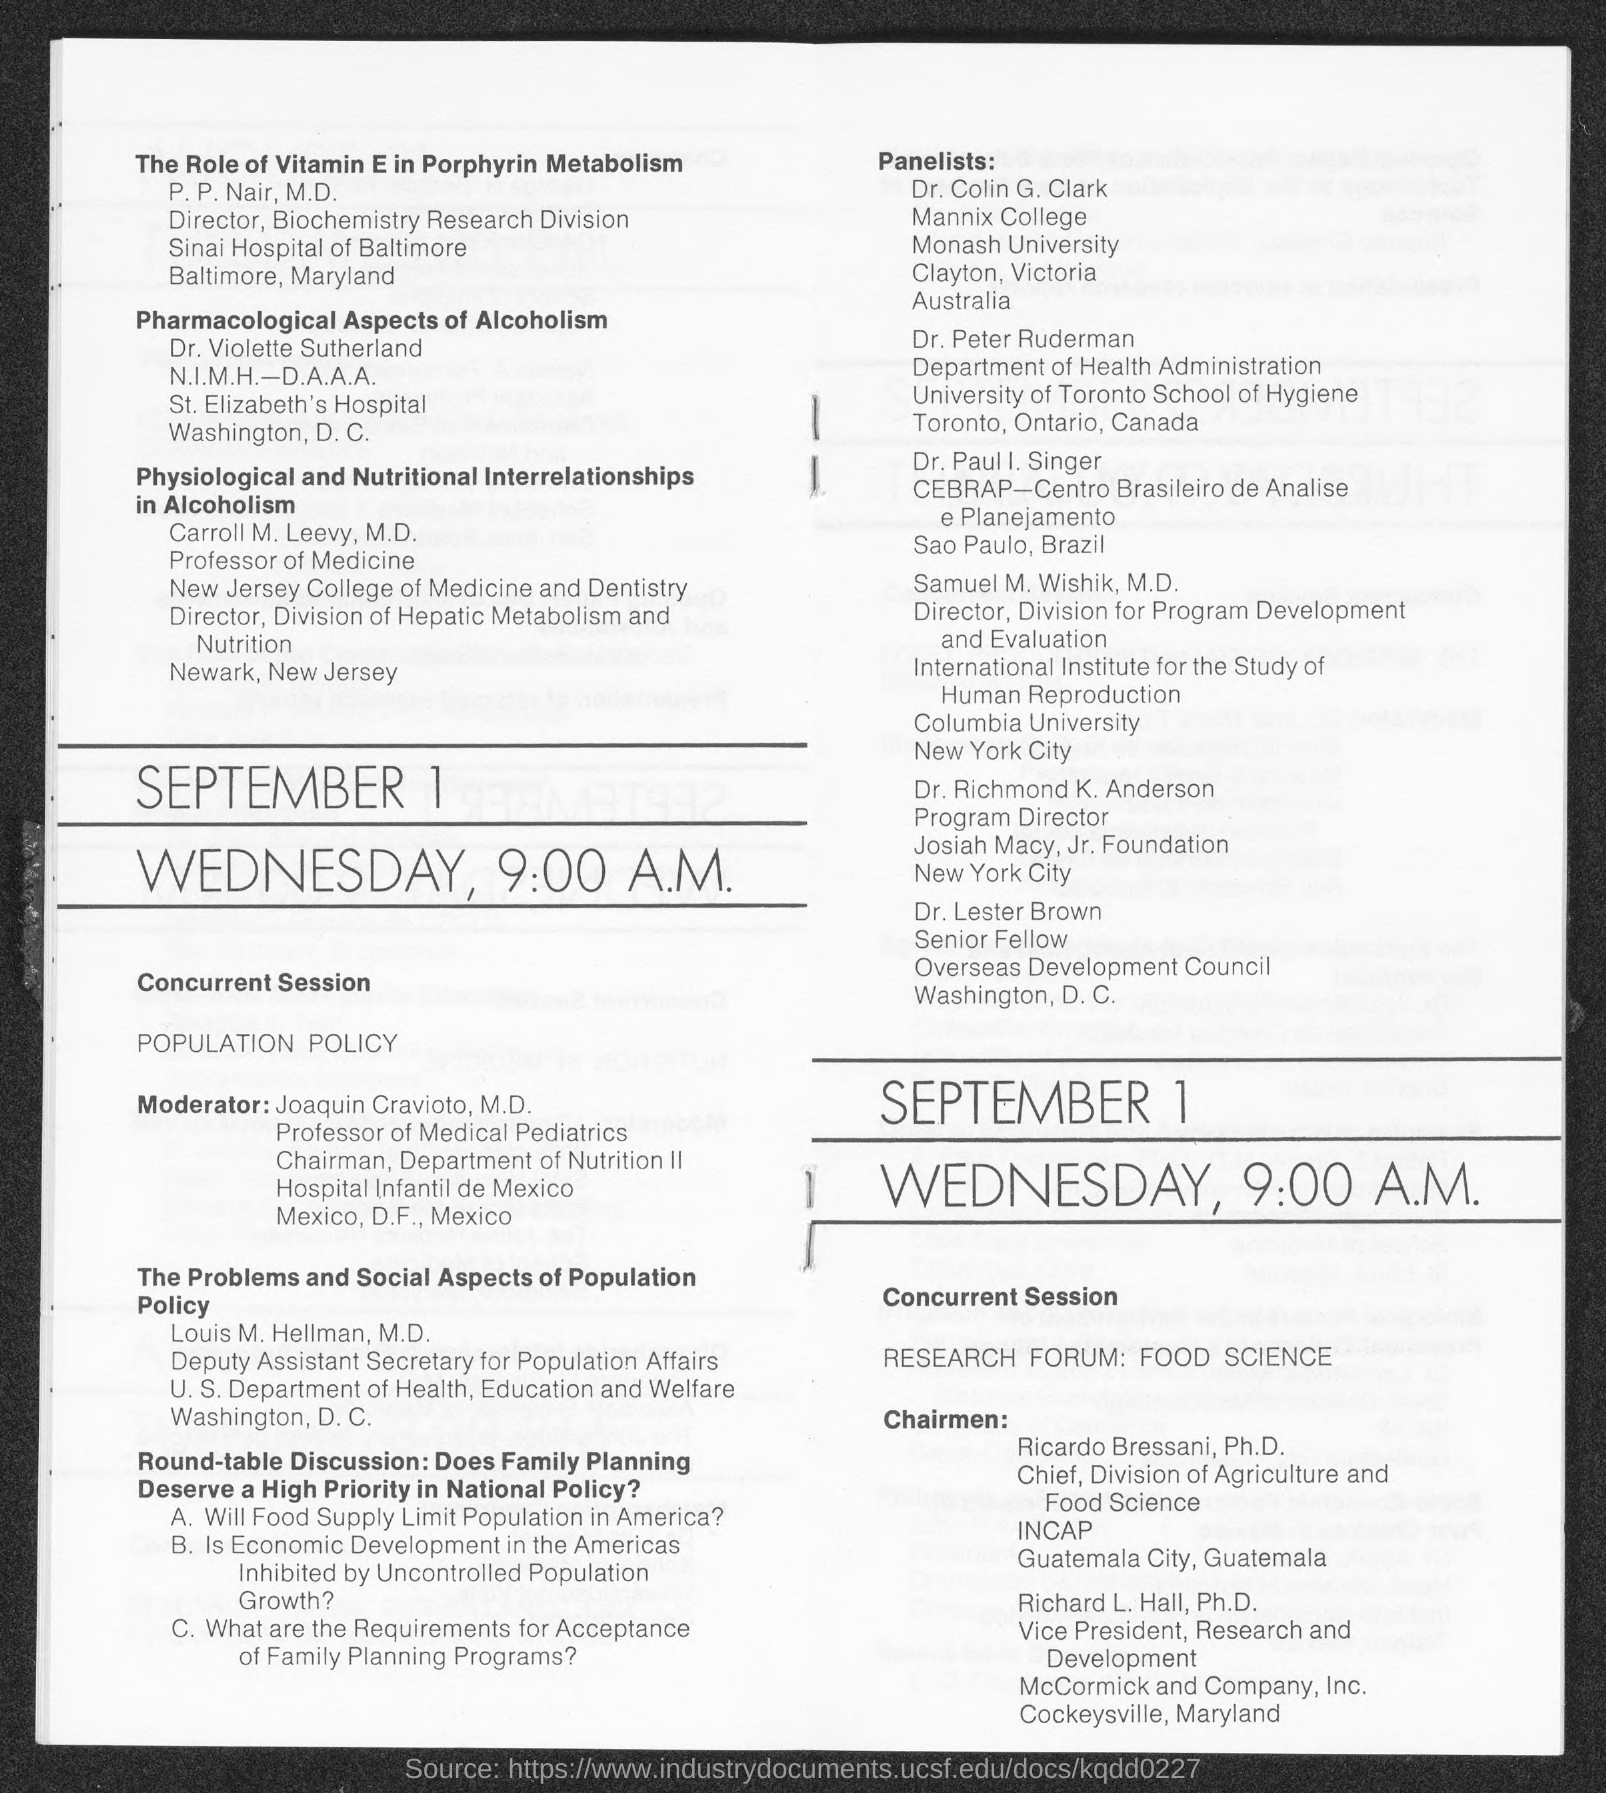What is the designation of p.p.nair ?
Provide a short and direct response. Director. To which university dr. colin g. clark belongs to ?
Provide a short and direct response. Monash University. What is the designation of carroll m. leevy ?
Make the answer very short. Professor of medicine. 